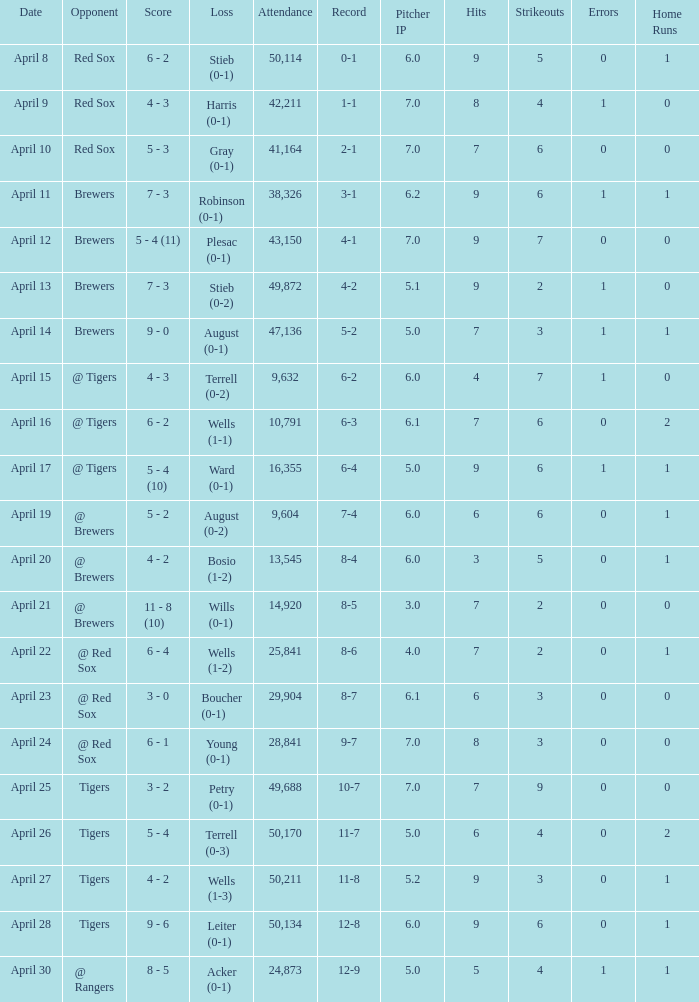Which opponent has an attendance greater than 29,904 and 11-8 as the record? Tigers. 